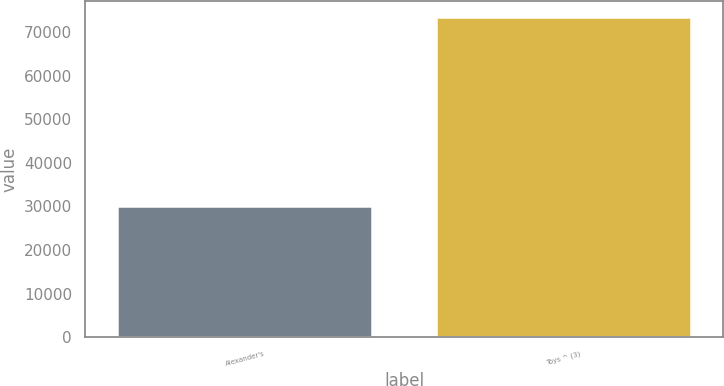Convert chart. <chart><loc_0><loc_0><loc_500><loc_500><bar_chart><fcel>Alexander's<fcel>Toys ^ (3)<nl><fcel>30009<fcel>73556<nl></chart> 